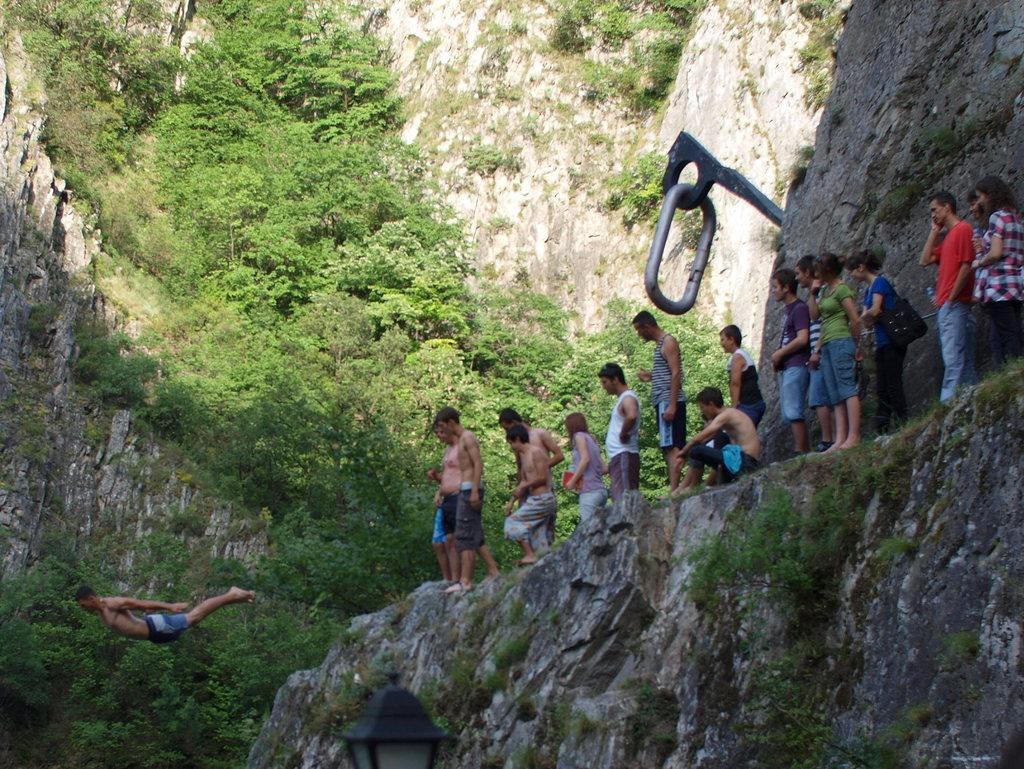What are the people in the image doing on the right side? There are people standing on the hill on the right side of the image. What action is being performed by the man on the left side? There is a man jumping on the left side of the image. What can be seen in the background of the image? There are trees and hills in the background of the image. What type of jewel is the deer wearing around its neck in the image? There is no deer present in the image, and therefore no such jewelry can be observed. How does the butter contribute to the overall composition of the image? There is no butter present in the image, so it cannot contribute to the composition. 